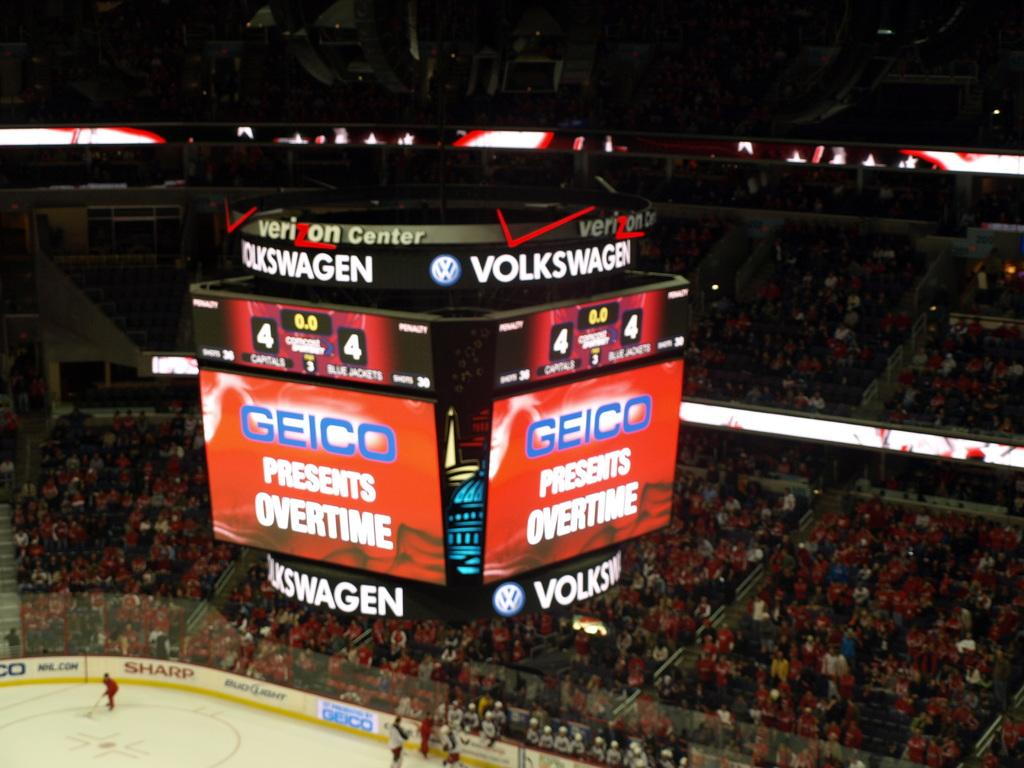<image>
Share a concise interpretation of the image provided. a geico scoreboard above the ice in an arena 